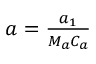<formula> <loc_0><loc_0><loc_500><loc_500>\begin{array} { r } { a = \frac { a _ { 1 } } { M _ { a } C _ { a } } } \end{array}</formula> 